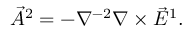<formula> <loc_0><loc_0><loc_500><loc_500>\vec { A } ^ { 2 } = - \nabla ^ { - 2 } \nabla \times \vec { E } ^ { 1 } .</formula> 